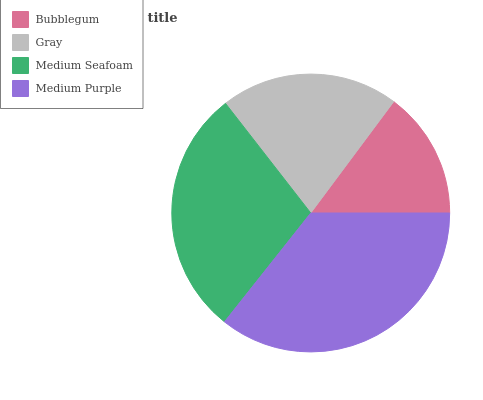Is Bubblegum the minimum?
Answer yes or no. Yes. Is Medium Purple the maximum?
Answer yes or no. Yes. Is Gray the minimum?
Answer yes or no. No. Is Gray the maximum?
Answer yes or no. No. Is Gray greater than Bubblegum?
Answer yes or no. Yes. Is Bubblegum less than Gray?
Answer yes or no. Yes. Is Bubblegum greater than Gray?
Answer yes or no. No. Is Gray less than Bubblegum?
Answer yes or no. No. Is Medium Seafoam the high median?
Answer yes or no. Yes. Is Gray the low median?
Answer yes or no. Yes. Is Bubblegum the high median?
Answer yes or no. No. Is Bubblegum the low median?
Answer yes or no. No. 